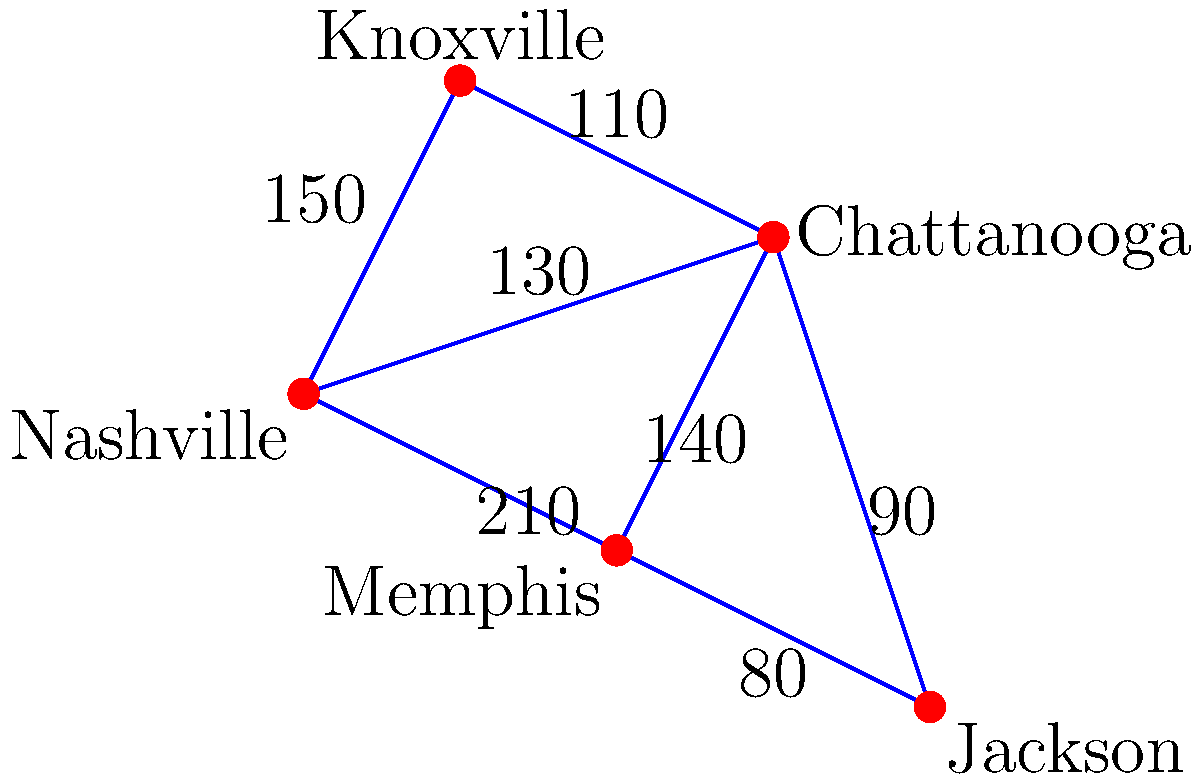You're tasked with designing the most efficient network of roads connecting car dealerships in major Tennessee cities. The graph shows distances (in miles) between cities. What's the minimum total distance needed to connect all cities, and which roads should be included in this network? To solve this problem, we'll use Kruskal's algorithm to find the Minimum Spanning Tree (MST) of the graph. This will give us the most efficient network connecting all cities with the minimum total distance.

Step 1: Sort all edges by weight (distance) in ascending order:
1. Memphis - Jackson: 80 miles
2. Chattanooga - Jackson: 90 miles
3. Knoxville - Chattanooga: 110 miles
4. Nashville - Chattanooga: 130 miles
5. Chattanooga - Memphis: 140 miles
6. Nashville - Knoxville: 150 miles
7. Nashville - Memphis: 210 miles

Step 2: Apply Kruskal's algorithm:
1. Add Memphis - Jackson (80 miles)
2. Add Chattanooga - Jackson (90 miles)
3. Add Knoxville - Chattanooga (110 miles)
4. Add Nashville - Chattanooga (130 miles)

At this point, all cities are connected, and we have our Minimum Spanning Tree.

Step 3: Calculate the total distance:
80 + 90 + 110 + 130 = 410 miles

Therefore, the minimum total distance needed to connect all cities is 410 miles, and the roads that should be included in this network are:
1. Memphis to Jackson
2. Chattanooga to Jackson
3. Knoxville to Chattanooga
4. Nashville to Chattanooga
Answer: 410 miles; Memphis-Jackson, Chattanooga-Jackson, Knoxville-Chattanooga, Nashville-Chattanooga 